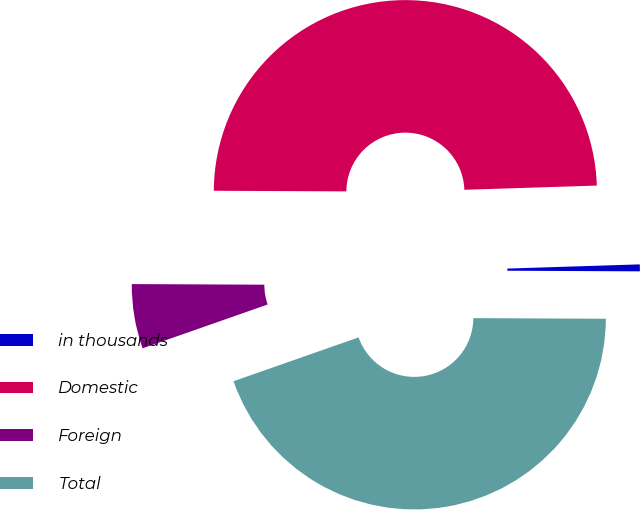<chart> <loc_0><loc_0><loc_500><loc_500><pie_chart><fcel>in thousands<fcel>Domestic<fcel>Foreign<fcel>Total<nl><fcel>0.58%<fcel>49.42%<fcel>5.44%<fcel>44.56%<nl></chart> 